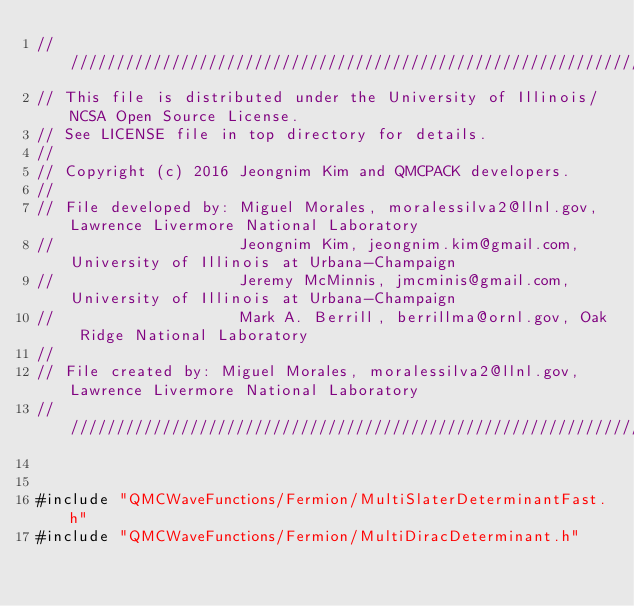<code> <loc_0><loc_0><loc_500><loc_500><_C++_>//////////////////////////////////////////////////////////////////////////////////////
// This file is distributed under the University of Illinois/NCSA Open Source License.
// See LICENSE file in top directory for details.
//
// Copyright (c) 2016 Jeongnim Kim and QMCPACK developers.
//
// File developed by: Miguel Morales, moralessilva2@llnl.gov, Lawrence Livermore National Laboratory
//                    Jeongnim Kim, jeongnim.kim@gmail.com, University of Illinois at Urbana-Champaign
//                    Jeremy McMinnis, jmcminis@gmail.com, University of Illinois at Urbana-Champaign
//                    Mark A. Berrill, berrillma@ornl.gov, Oak Ridge National Laboratory
//
// File created by: Miguel Morales, moralessilva2@llnl.gov, Lawrence Livermore National Laboratory
//////////////////////////////////////////////////////////////////////////////////////


#include "QMCWaveFunctions/Fermion/MultiSlaterDeterminantFast.h"
#include "QMCWaveFunctions/Fermion/MultiDiracDeterminant.h"</code> 